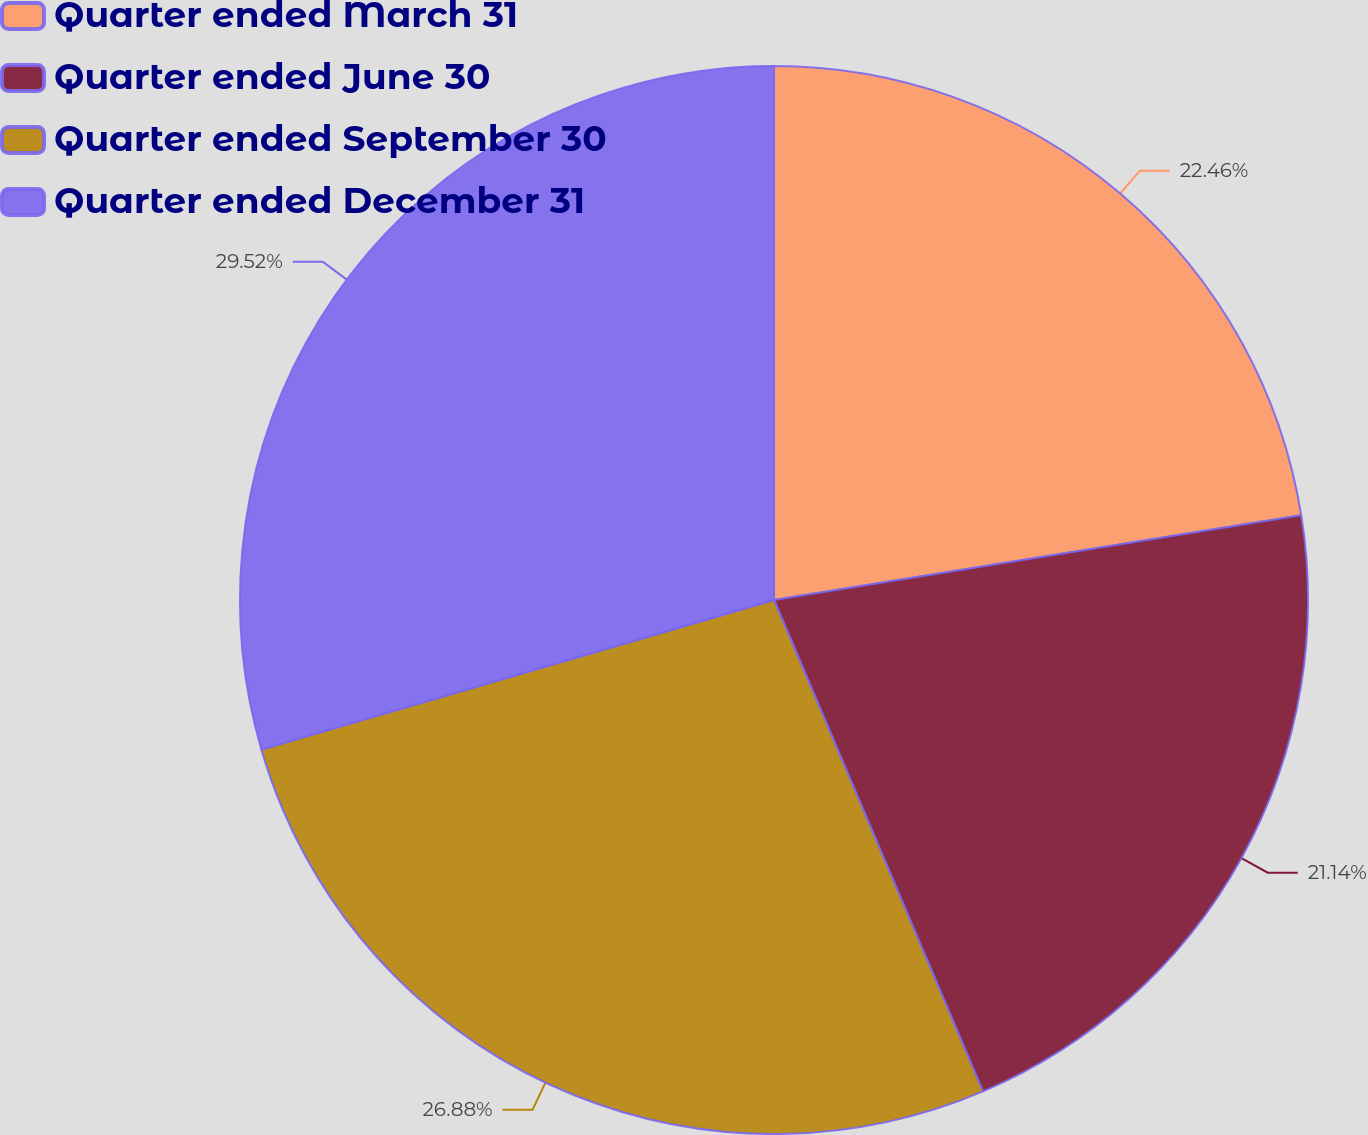Convert chart to OTSL. <chart><loc_0><loc_0><loc_500><loc_500><pie_chart><fcel>Quarter ended March 31<fcel>Quarter ended June 30<fcel>Quarter ended September 30<fcel>Quarter ended December 31<nl><fcel>22.46%<fcel>21.14%<fcel>26.88%<fcel>29.52%<nl></chart> 